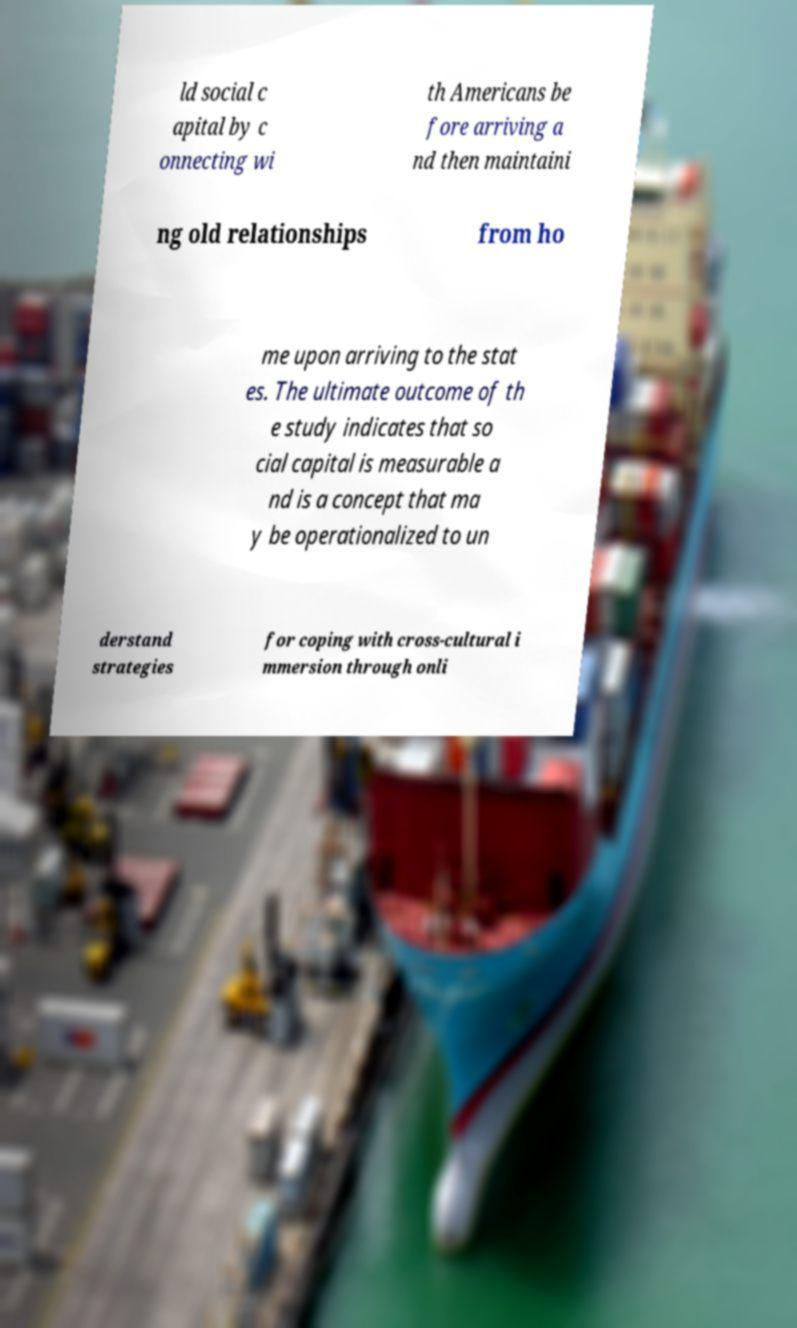I need the written content from this picture converted into text. Can you do that? ld social c apital by c onnecting wi th Americans be fore arriving a nd then maintaini ng old relationships from ho me upon arriving to the stat es. The ultimate outcome of th e study indicates that so cial capital is measurable a nd is a concept that ma y be operationalized to un derstand strategies for coping with cross-cultural i mmersion through onli 